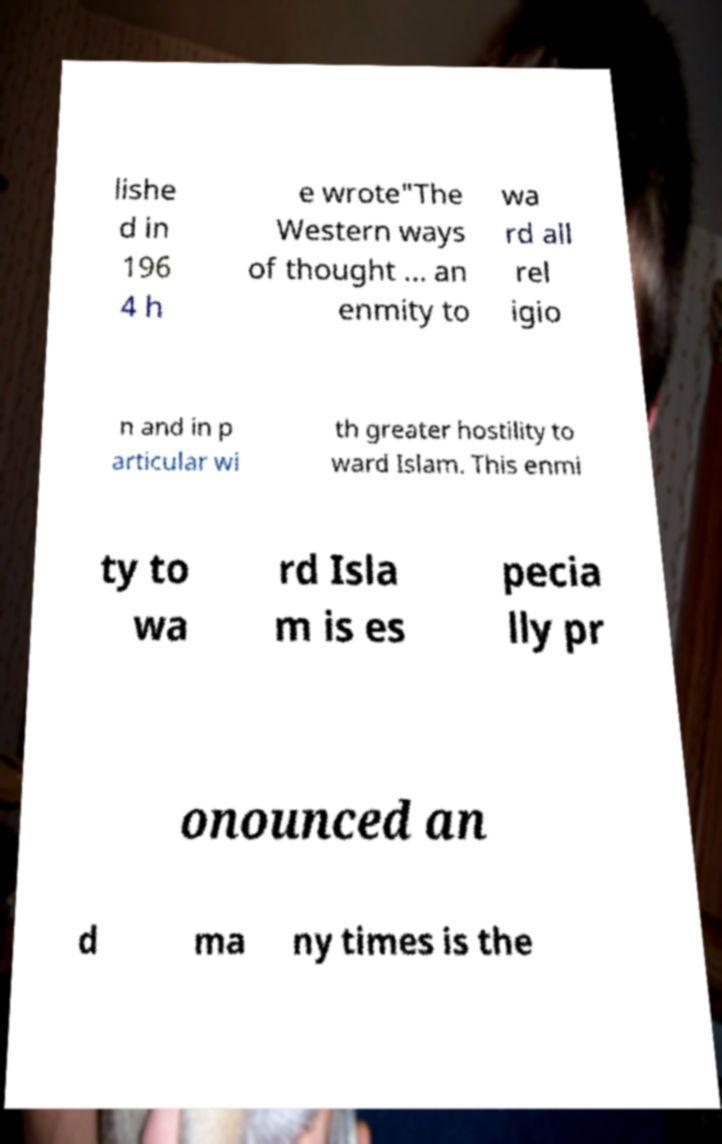For documentation purposes, I need the text within this image transcribed. Could you provide that? lishe d in 196 4 h e wrote"The Western ways of thought … an enmity to wa rd all rel igio n and in p articular wi th greater hostility to ward Islam. This enmi ty to wa rd Isla m is es pecia lly pr onounced an d ma ny times is the 